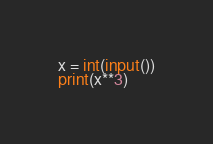<code> <loc_0><loc_0><loc_500><loc_500><_Python_>x = int(input())
print(x**3)

</code> 